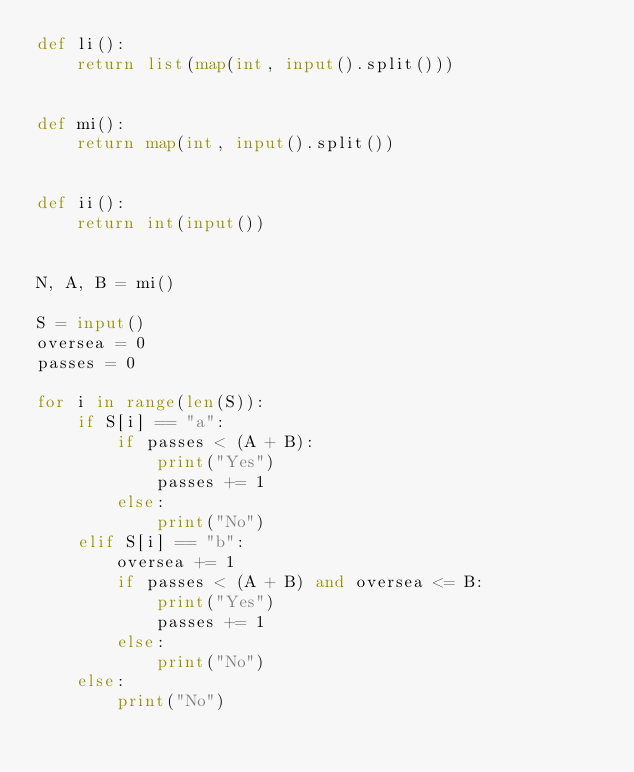Convert code to text. <code><loc_0><loc_0><loc_500><loc_500><_Python_>def li():
    return list(map(int, input().split()))


def mi():
    return map(int, input().split())


def ii():
    return int(input())


N, A, B = mi()

S = input()
oversea = 0
passes = 0

for i in range(len(S)):
    if S[i] == "a":
        if passes < (A + B):
            print("Yes")
            passes += 1
        else:
            print("No")
    elif S[i] == "b":
        oversea += 1
        if passes < (A + B) and oversea <= B:
            print("Yes")
            passes += 1
        else:
            print("No")
    else:
        print("No")
</code> 